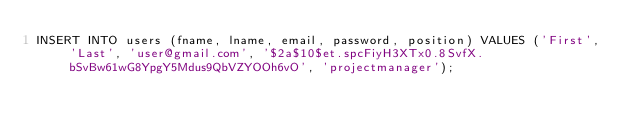Convert code to text. <code><loc_0><loc_0><loc_500><loc_500><_SQL_>INSERT INTO users (fname, lname, email, password, position) VALUES ('First', 'Last', 'user@gmail.com', '$2a$10$et.spcFiyH3XTx0.8SvfX.bSvBw61wG8YpgY5Mdus9QbVZYOOh6vO', 'projectmanager');</code> 